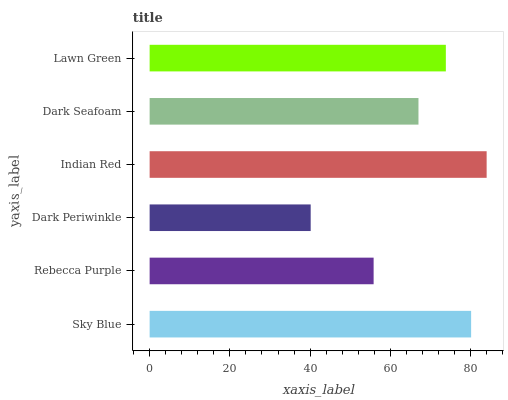Is Dark Periwinkle the minimum?
Answer yes or no. Yes. Is Indian Red the maximum?
Answer yes or no. Yes. Is Rebecca Purple the minimum?
Answer yes or no. No. Is Rebecca Purple the maximum?
Answer yes or no. No. Is Sky Blue greater than Rebecca Purple?
Answer yes or no. Yes. Is Rebecca Purple less than Sky Blue?
Answer yes or no. Yes. Is Rebecca Purple greater than Sky Blue?
Answer yes or no. No. Is Sky Blue less than Rebecca Purple?
Answer yes or no. No. Is Lawn Green the high median?
Answer yes or no. Yes. Is Dark Seafoam the low median?
Answer yes or no. Yes. Is Dark Periwinkle the high median?
Answer yes or no. No. Is Dark Periwinkle the low median?
Answer yes or no. No. 